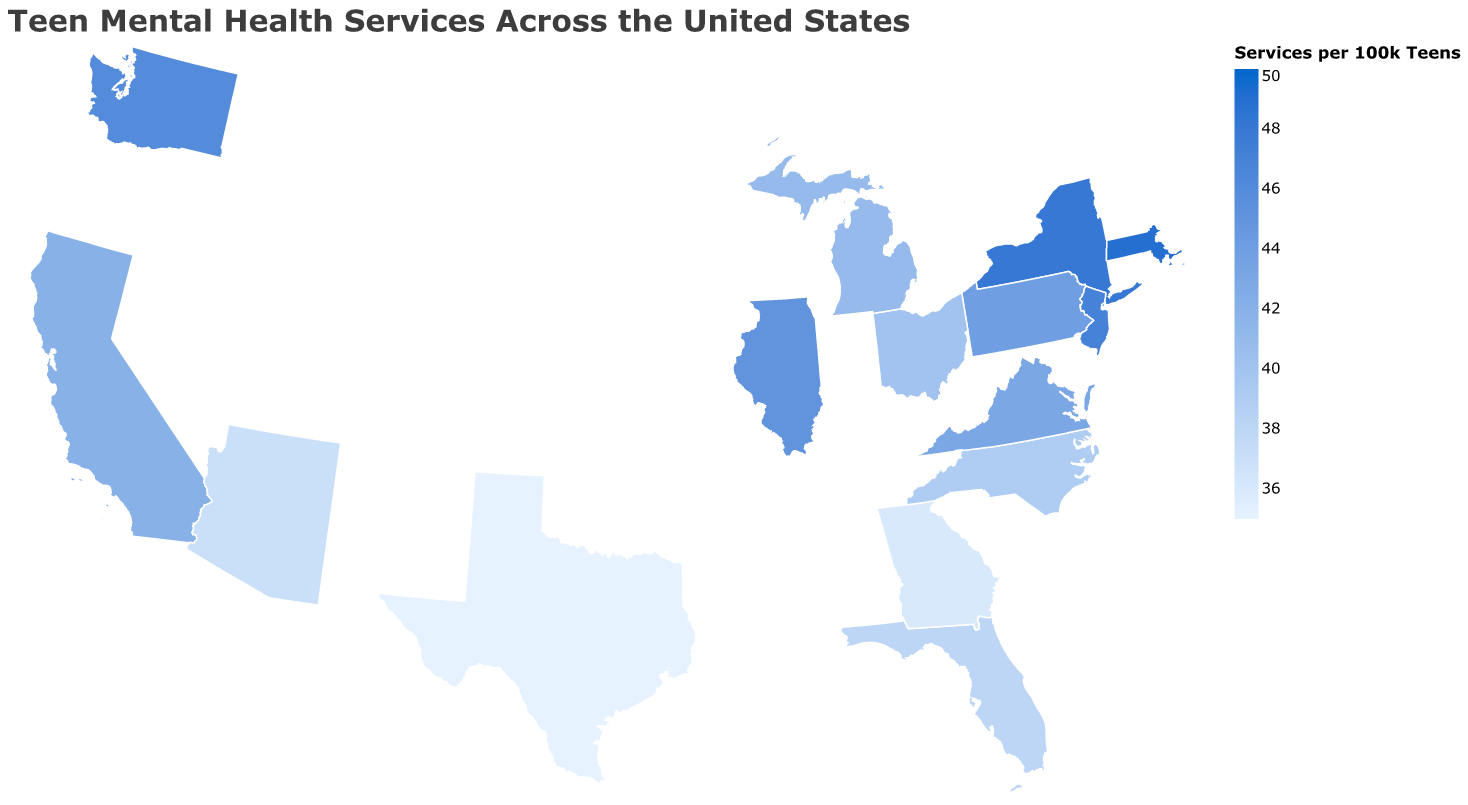What is the title of the figure? The title of the figure is usually displayed at the top. In this case, it reads "Teen Mental Health Services Across the United States".
Answer: Teen Mental Health Services Across the United States Which state has the highest number of mental health services per 100k teens and what is the value? By looking at the color intensity and the quantitative values in the tooltip, Massachusetts has the highest number of mental health services per 100k teens with a value of 49.
Answer: Massachusetts, 49 Which states have a counselor-to-student ratio better than 1:420? By examining the tooltips for each state and comparing the counselor-to-student ratios, the states with ratios better than 1:420 are Massachusetts (1:390), New York (1:400), New Jersey (1:410), and Washington (1:415).
Answer: Massachusetts, New York, New Jersey, Washington What is the range of telehealth availability percentages across the states? By checking the tooltip for each state under the column for "Telehealth Availability (%)", the lowest value is 72% (Texas), and the highest value is 86% (Massachusetts), so the range is 86% - 72% = 14%.
Answer: 14% Is there any state with both high mental health service availability and telehealth availability above 80%? Checking the states with high mental health services per 100k teens and cross-referencing them with telehealth availability above 80%, states that meet both criteria are New York (85% telehealth, 48 services), New Jersey (84% telehealth, 47 services), Pennsylvania (82% telehealth, 44 services), and Washington (83% telehealth, 46 services).
Answer: New York, New Jersey, Pennsylvania, Washington What is the average number of mental health services per 100k teens for the states listed? Summing up all the values of "Mental Health Services per 100k Teens" (42 + 35 + 48 + 38 + 45 + 44 + 40 + 36 + 39 + 41 + 47 + 43 + 46 + 49 + 37 = 650) and dividing by the number of states (15), the average is 650 / 15 = approximately 43.33.
Answer: Approximately 43.33 How do the mental health services per 100k teens in California compare to those in Texas? Checking the tooltip for both states, California has 42 services per 100k teens and Texas has 35 services per 100k teens. California has 7 more services per 100k teens compared to Texas.
Answer: California has 7 more Which state has the lowest school-based services percentage and what is that percentage? By reviewing the tooltip for each state, Texas has the lowest school-based services percentage at 58%.
Answer: Texas, 58% What is the total number of services per 100k teens for New York, Illinois, and Ohio combined? Adding the number of services per 100k teens for New York (48), Illinois (45), and Ohio (40) gives 48 + 45 + 40 = 133.
Answer: 133 Which state has the best counselor-to-student ratio and what is that ratio? By analyzing the tooltips for each state, Massachusetts has the best counselor-to-student ratio of 1:390.
Answer: Massachusetts, 1:390 